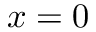Convert formula to latex. <formula><loc_0><loc_0><loc_500><loc_500>x = 0</formula> 